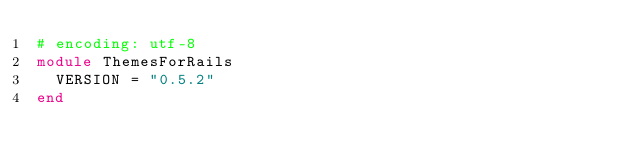Convert code to text. <code><loc_0><loc_0><loc_500><loc_500><_Ruby_># encoding: utf-8
module ThemesForRails
  VERSION = "0.5.2"
end
</code> 